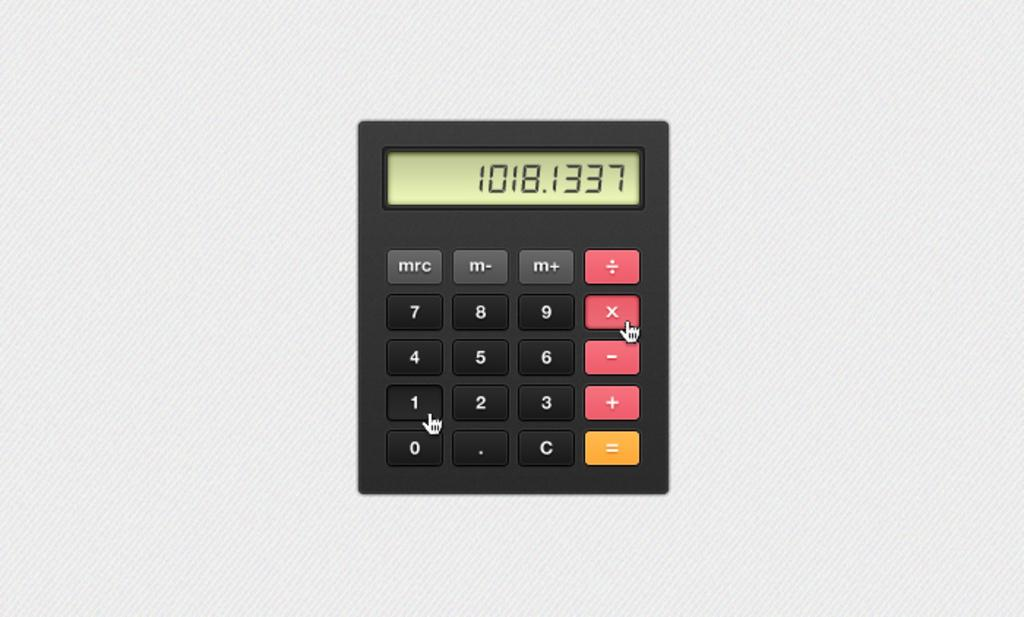<image>
Give a short and clear explanation of the subsequent image. An app widget with the numbers 1018.1337 and keys that say mrc and m- and m+. 